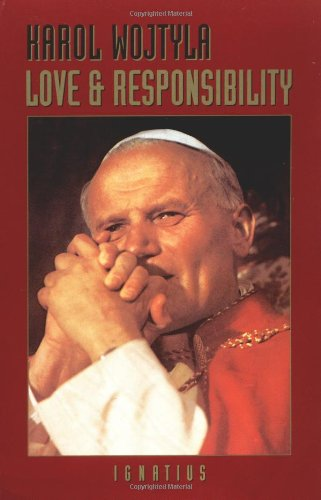How has the author's position as a Pope influenced the writings in this book? Karol Wojtyla's position as Pope John Paul II profoundly influenced his writings, bringing a unique blend of doctrinal authority and personal insight to the discussions on moral theology and ethical responsibility in human relationships. 